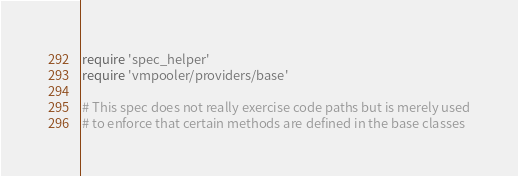Convert code to text. <code><loc_0><loc_0><loc_500><loc_500><_Ruby_>require 'spec_helper'
require 'vmpooler/providers/base'

# This spec does not really exercise code paths but is merely used
# to enforce that certain methods are defined in the base classes
</code> 